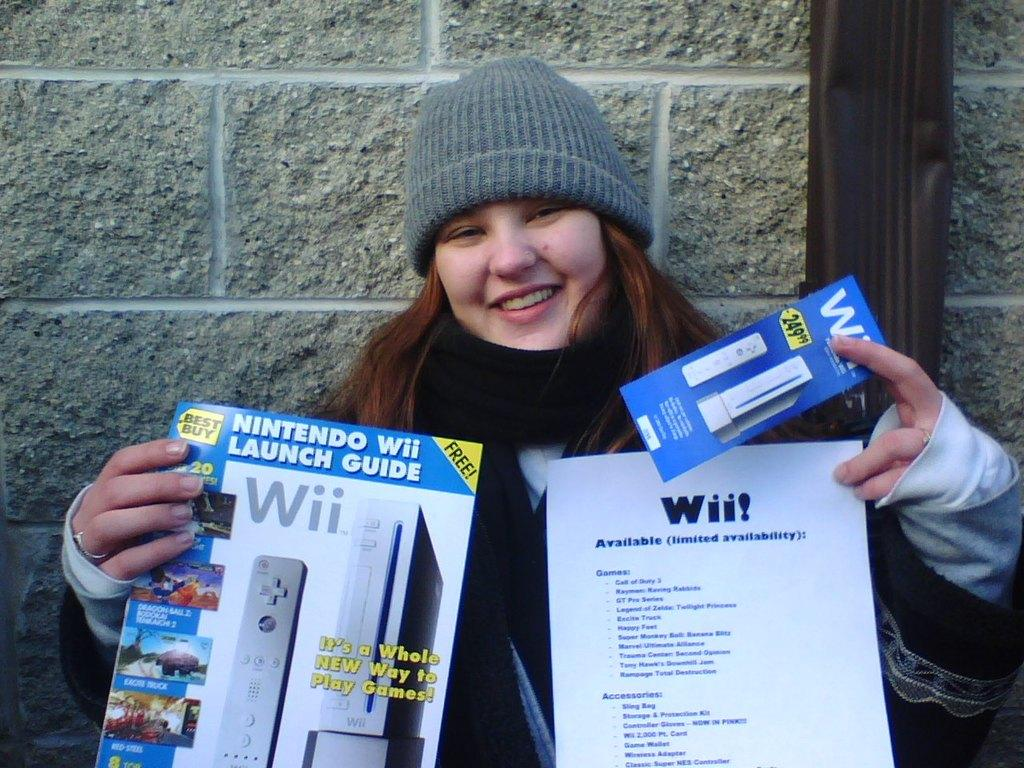What is the main subject of the image? There is a person in the image. What is the person doing in the image? The person is holding some objects. What can be seen in the background of the image? There is a wall in the background of the image. Is there anything on the wall in the background? Yes, there is an object on the wall in the background. Can you hear the person singing a song in the image? There is no indication of sound or a song in the image, as it is a still photograph. 